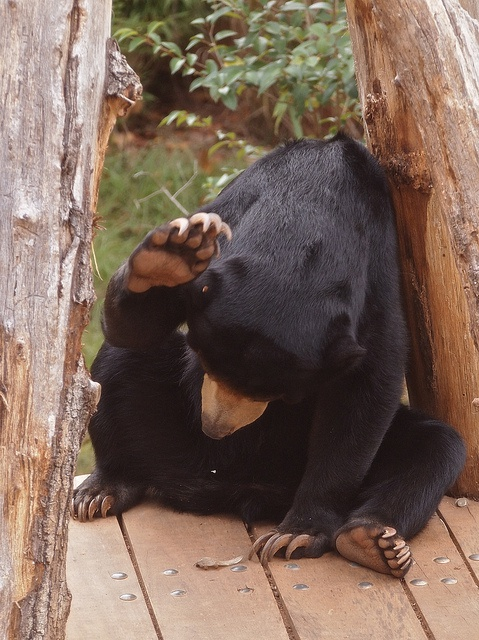Describe the objects in this image and their specific colors. I can see a bear in lightgray, black, gray, and maroon tones in this image. 